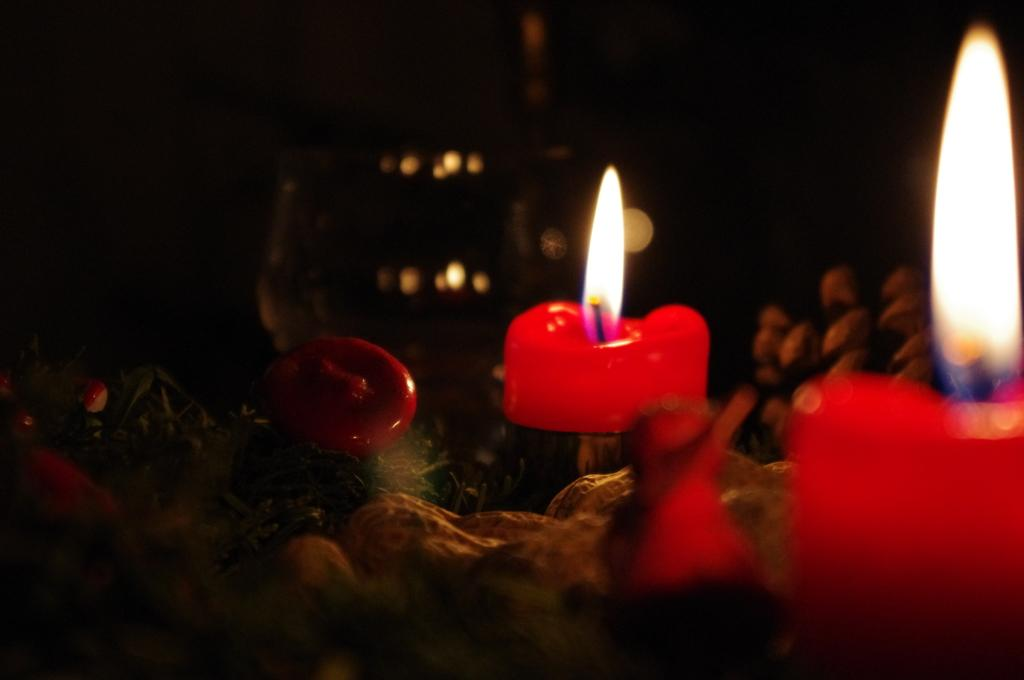What color are the candles in the image? The candles in the image are red. What is happening to the candles in the image? The candles are burning. Can you see a bee buzzing around the candles in the image? There is no bee present in the image. What type of machine is operating near the candles in the image? There is no machine present in the image. 